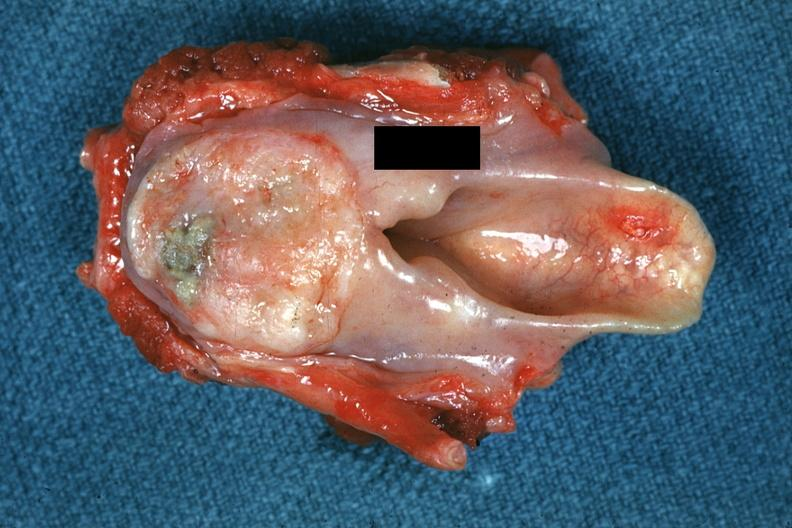what is present?
Answer the question using a single word or phrase. Hypopharynx 